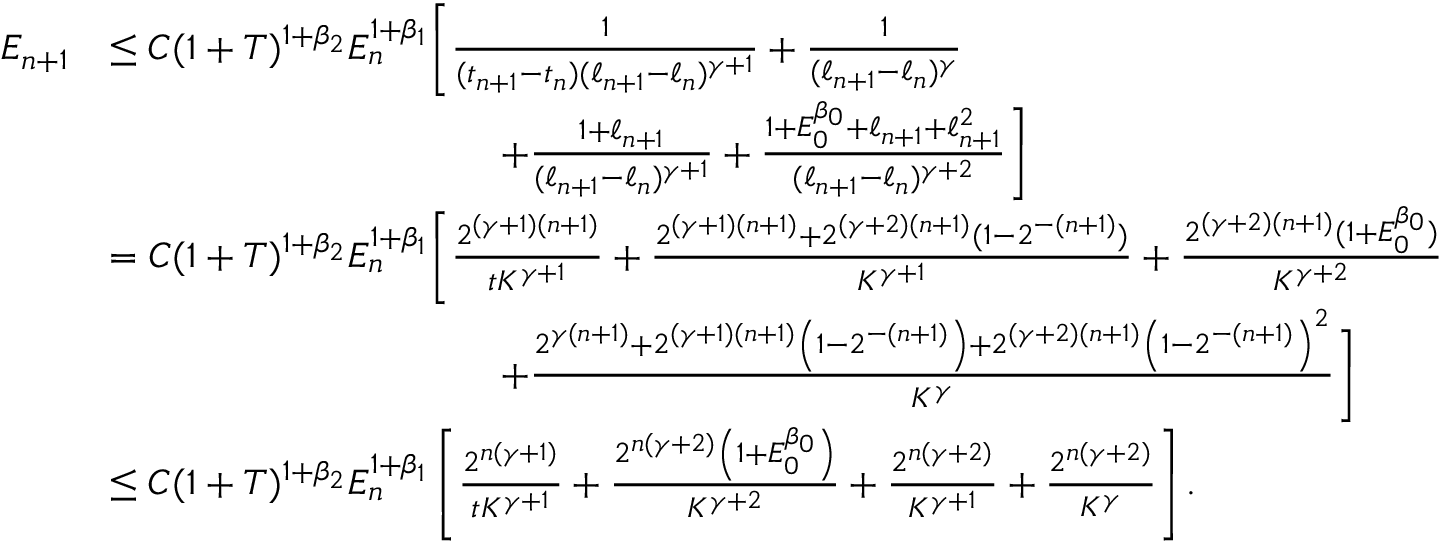Convert formula to latex. <formula><loc_0><loc_0><loc_500><loc_500>\begin{array} { r l } { E _ { n + 1 } } & { \leq C ( 1 + T ) ^ { 1 + \beta _ { 2 } } E _ { n } ^ { 1 + \beta _ { 1 } } \left [ \frac { 1 } { ( t _ { n + 1 } - t _ { n } ) ( \ell _ { n + 1 } - \ell _ { n } ) ^ { \gamma + 1 } } + \frac { 1 } { ( \ell _ { n + 1 } - \ell _ { n } ) ^ { \gamma } } } \\ & { \quad + \frac { 1 + \ell _ { n + 1 } } { ( \ell _ { n + 1 } - \ell _ { n } ) ^ { \gamma + 1 } } + \frac { 1 + E _ { 0 } ^ { \beta _ { 0 } } + \ell _ { n + 1 } + \ell _ { n + 1 } ^ { 2 } } { ( \ell _ { n + 1 } - \ell _ { n } ) ^ { \gamma + 2 } } \right ] } \\ & { = C ( 1 + T ) ^ { 1 + \beta _ { 2 } } E _ { n } ^ { 1 + \beta _ { 1 } } \left [ \frac { 2 ^ { ( \gamma + 1 ) ( n + 1 ) } } { t K ^ { \gamma + 1 } } + \frac { 2 ^ { ( \gamma + 1 ) ( n + 1 ) } + 2 ^ { ( \gamma + 2 ) ( n + 1 ) } ( 1 - 2 ^ { - ( n + 1 ) } ) } { K ^ { \gamma + 1 } } + \frac { 2 ^ { ( \gamma + 2 ) ( n + 1 ) } ( 1 + E _ { 0 } ^ { \beta _ { 0 } } ) } { K ^ { \gamma + 2 } } } \\ & { \quad + \frac { 2 ^ { \gamma ( n + 1 ) } + 2 ^ { ( \gamma + 1 ) ( n + 1 ) } \left ( 1 - 2 ^ { - ( n + 1 ) } \right ) + 2 ^ { ( \gamma + 2 ) ( n + 1 ) } \left ( 1 - 2 ^ { - ( n + 1 ) } \right ) ^ { 2 } } { K ^ { \gamma } } \right ] } \\ & { \leq C ( 1 + T ) ^ { 1 + \beta _ { 2 } } E _ { n } ^ { 1 + \beta _ { 1 } } \left [ \frac { 2 ^ { n ( \gamma + 1 ) } } { t K ^ { \gamma + 1 } } + \frac { 2 ^ { n ( \gamma + 2 ) } \left ( 1 + E _ { 0 } ^ { \beta _ { 0 } } \right ) } { K ^ { \gamma + 2 } } + \frac { 2 ^ { n ( \gamma + 2 ) } } { K ^ { \gamma + 1 } } + \frac { 2 ^ { n ( \gamma + 2 ) } } { K ^ { \gamma } } \right ] . } \end{array}</formula> 